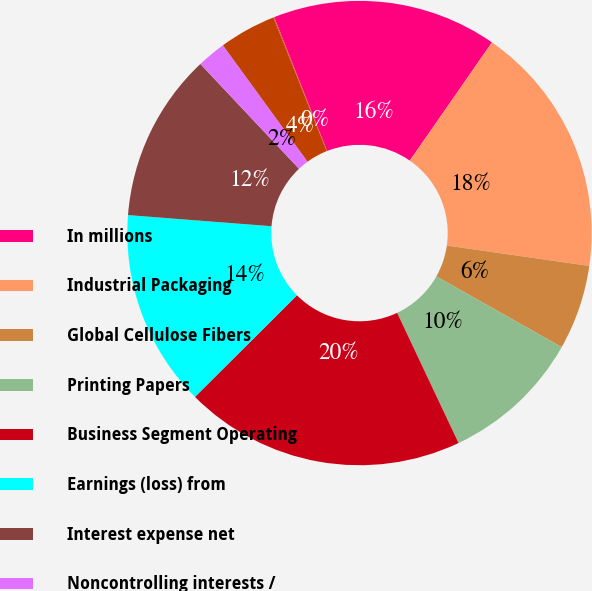Convert chart. <chart><loc_0><loc_0><loc_500><loc_500><pie_chart><fcel>In millions<fcel>Industrial Packaging<fcel>Global Cellulose Fibers<fcel>Printing Papers<fcel>Business Segment Operating<fcel>Earnings (loss) from<fcel>Interest expense net<fcel>Noncontrolling interests /<fcel>Corporate items net (a)<fcel>Corporate special items net<nl><fcel>15.65%<fcel>17.6%<fcel>5.91%<fcel>9.81%<fcel>19.55%<fcel>13.7%<fcel>11.75%<fcel>2.01%<fcel>3.96%<fcel>0.06%<nl></chart> 